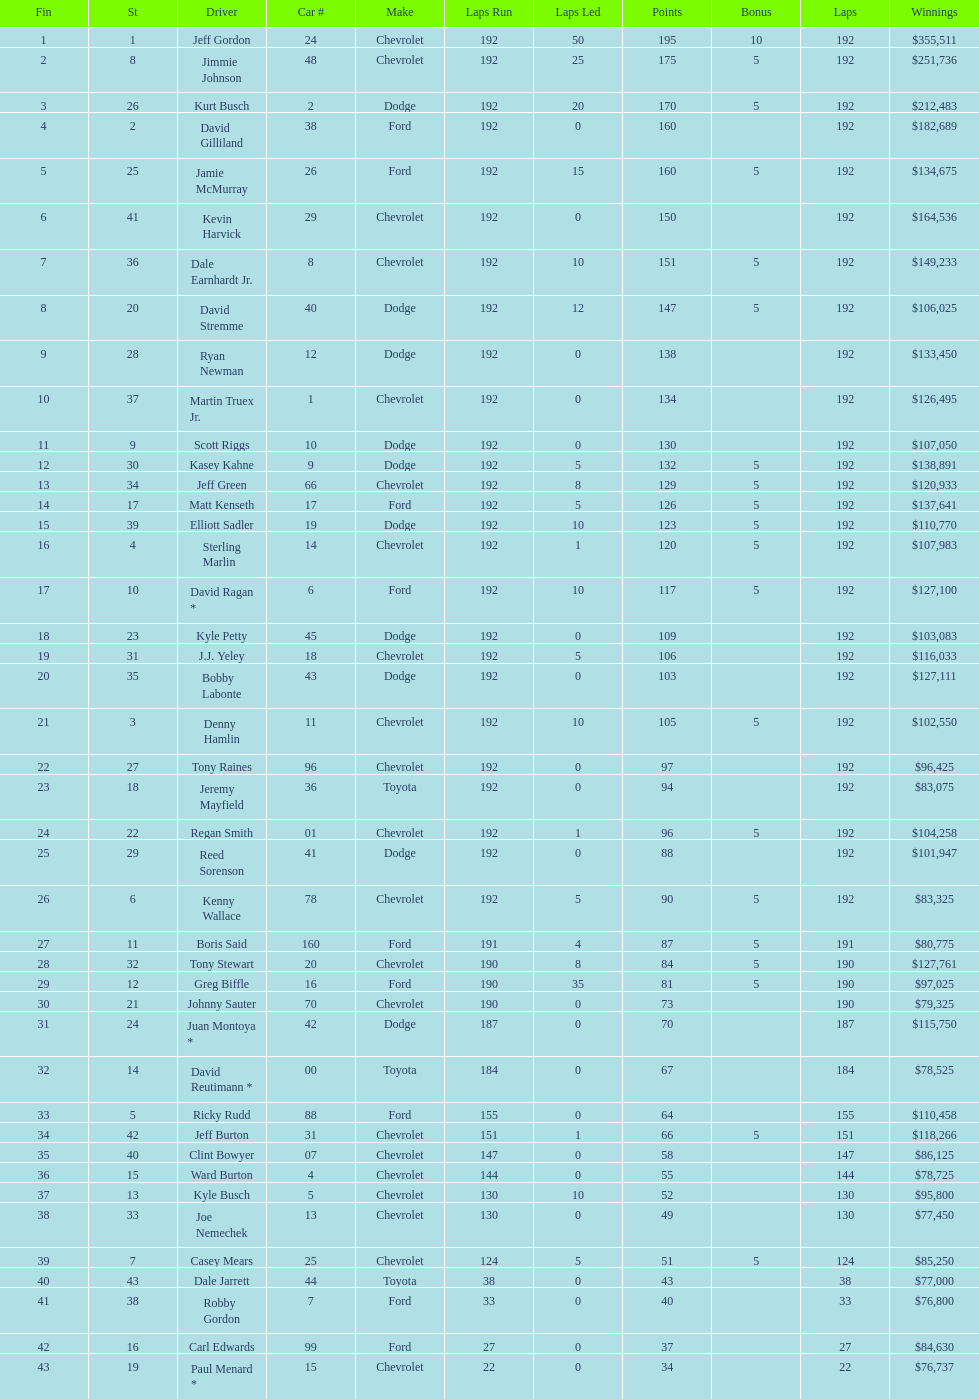Who is first in number of winnings on this list? Jeff Gordon. Can you parse all the data within this table? {'header': ['Fin', 'St', 'Driver', 'Car #', 'Make', 'Laps Run', 'Laps Led', 'Points', 'Bonus', 'Laps', 'Winnings'], 'rows': [['1', '1', 'Jeff Gordon', '24', 'Chevrolet', '192', '50', '195', '10', '192', '$355,511'], ['2', '8', 'Jimmie Johnson', '48', 'Chevrolet', '192', '25', '175', '5', '192', '$251,736'], ['3', '26', 'Kurt Busch', '2', 'Dodge', '192', '20', '170', '5', '192', '$212,483'], ['4', '2', 'David Gilliland', '38', 'Ford', '192', '0', '160', '', '192', '$182,689'], ['5', '25', 'Jamie McMurray', '26', 'Ford', '192', '15', '160', '5', '192', '$134,675'], ['6', '41', 'Kevin Harvick', '29', 'Chevrolet', '192', '0', '150', '', '192', '$164,536'], ['7', '36', 'Dale Earnhardt Jr.', '8', 'Chevrolet', '192', '10', '151', '5', '192', '$149,233'], ['8', '20', 'David Stremme', '40', 'Dodge', '192', '12', '147', '5', '192', '$106,025'], ['9', '28', 'Ryan Newman', '12', 'Dodge', '192', '0', '138', '', '192', '$133,450'], ['10', '37', 'Martin Truex Jr.', '1', 'Chevrolet', '192', '0', '134', '', '192', '$126,495'], ['11', '9', 'Scott Riggs', '10', 'Dodge', '192', '0', '130', '', '192', '$107,050'], ['12', '30', 'Kasey Kahne', '9', 'Dodge', '192', '5', '132', '5', '192', '$138,891'], ['13', '34', 'Jeff Green', '66', 'Chevrolet', '192', '8', '129', '5', '192', '$120,933'], ['14', '17', 'Matt Kenseth', '17', 'Ford', '192', '5', '126', '5', '192', '$137,641'], ['15', '39', 'Elliott Sadler', '19', 'Dodge', '192', '10', '123', '5', '192', '$110,770'], ['16', '4', 'Sterling Marlin', '14', 'Chevrolet', '192', '1', '120', '5', '192', '$107,983'], ['17', '10', 'David Ragan *', '6', 'Ford', '192', '10', '117', '5', '192', '$127,100'], ['18', '23', 'Kyle Petty', '45', 'Dodge', '192', '0', '109', '', '192', '$103,083'], ['19', '31', 'J.J. Yeley', '18', 'Chevrolet', '192', '5', '106', '', '192', '$116,033'], ['20', '35', 'Bobby Labonte', '43', 'Dodge', '192', '0', '103', '', '192', '$127,111'], ['21', '3', 'Denny Hamlin', '11', 'Chevrolet', '192', '10', '105', '5', '192', '$102,550'], ['22', '27', 'Tony Raines', '96', 'Chevrolet', '192', '0', '97', '', '192', '$96,425'], ['23', '18', 'Jeremy Mayfield', '36', 'Toyota', '192', '0', '94', '', '192', '$83,075'], ['24', '22', 'Regan Smith', '01', 'Chevrolet', '192', '1', '96', '5', '192', '$104,258'], ['25', '29', 'Reed Sorenson', '41', 'Dodge', '192', '0', '88', '', '192', '$101,947'], ['26', '6', 'Kenny Wallace', '78', 'Chevrolet', '192', '5', '90', '5', '192', '$83,325'], ['27', '11', 'Boris Said', '160', 'Ford', '191', '4', '87', '5', '191', '$80,775'], ['28', '32', 'Tony Stewart', '20', 'Chevrolet', '190', '8', '84', '5', '190', '$127,761'], ['29', '12', 'Greg Biffle', '16', 'Ford', '190', '35', '81', '5', '190', '$97,025'], ['30', '21', 'Johnny Sauter', '70', 'Chevrolet', '190', '0', '73', '', '190', '$79,325'], ['31', '24', 'Juan Montoya *', '42', 'Dodge', '187', '0', '70', '', '187', '$115,750'], ['32', '14', 'David Reutimann *', '00', 'Toyota', '184', '0', '67', '', '184', '$78,525'], ['33', '5', 'Ricky Rudd', '88', 'Ford', '155', '0', '64', '', '155', '$110,458'], ['34', '42', 'Jeff Burton', '31', 'Chevrolet', '151', '1', '66', '5', '151', '$118,266'], ['35', '40', 'Clint Bowyer', '07', 'Chevrolet', '147', '0', '58', '', '147', '$86,125'], ['36', '15', 'Ward Burton', '4', 'Chevrolet', '144', '0', '55', '', '144', '$78,725'], ['37', '13', 'Kyle Busch', '5', 'Chevrolet', '130', '10', '52', '', '130', '$95,800'], ['38', '33', 'Joe Nemechek', '13', 'Chevrolet', '130', '0', '49', '', '130', '$77,450'], ['39', '7', 'Casey Mears', '25', 'Chevrolet', '124', '5', '51', '5', '124', '$85,250'], ['40', '43', 'Dale Jarrett', '44', 'Toyota', '38', '0', '43', '', '38', '$77,000'], ['41', '38', 'Robby Gordon', '7', 'Ford', '33', '0', '40', '', '33', '$76,800'], ['42', '16', 'Carl Edwards', '99', 'Ford', '27', '0', '37', '', '27', '$84,630'], ['43', '19', 'Paul Menard *', '15', 'Chevrolet', '22', '0', '34', '', '22', '$76,737']]} 